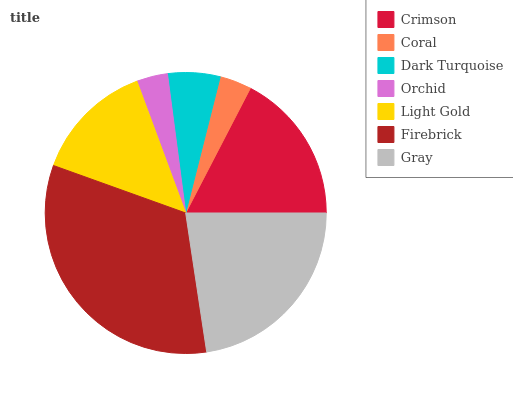Is Orchid the minimum?
Answer yes or no. Yes. Is Firebrick the maximum?
Answer yes or no. Yes. Is Coral the minimum?
Answer yes or no. No. Is Coral the maximum?
Answer yes or no. No. Is Crimson greater than Coral?
Answer yes or no. Yes. Is Coral less than Crimson?
Answer yes or no. Yes. Is Coral greater than Crimson?
Answer yes or no. No. Is Crimson less than Coral?
Answer yes or no. No. Is Light Gold the high median?
Answer yes or no. Yes. Is Light Gold the low median?
Answer yes or no. Yes. Is Orchid the high median?
Answer yes or no. No. Is Coral the low median?
Answer yes or no. No. 